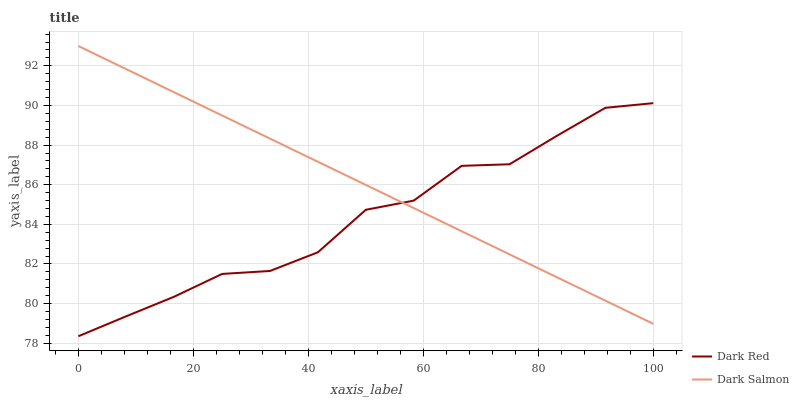Does Dark Red have the minimum area under the curve?
Answer yes or no. Yes. Does Dark Salmon have the maximum area under the curve?
Answer yes or no. Yes. Does Dark Salmon have the minimum area under the curve?
Answer yes or no. No. Is Dark Salmon the smoothest?
Answer yes or no. Yes. Is Dark Red the roughest?
Answer yes or no. Yes. Is Dark Salmon the roughest?
Answer yes or no. No. Does Dark Red have the lowest value?
Answer yes or no. Yes. Does Dark Salmon have the lowest value?
Answer yes or no. No. Does Dark Salmon have the highest value?
Answer yes or no. Yes. Does Dark Red intersect Dark Salmon?
Answer yes or no. Yes. Is Dark Red less than Dark Salmon?
Answer yes or no. No. Is Dark Red greater than Dark Salmon?
Answer yes or no. No. 